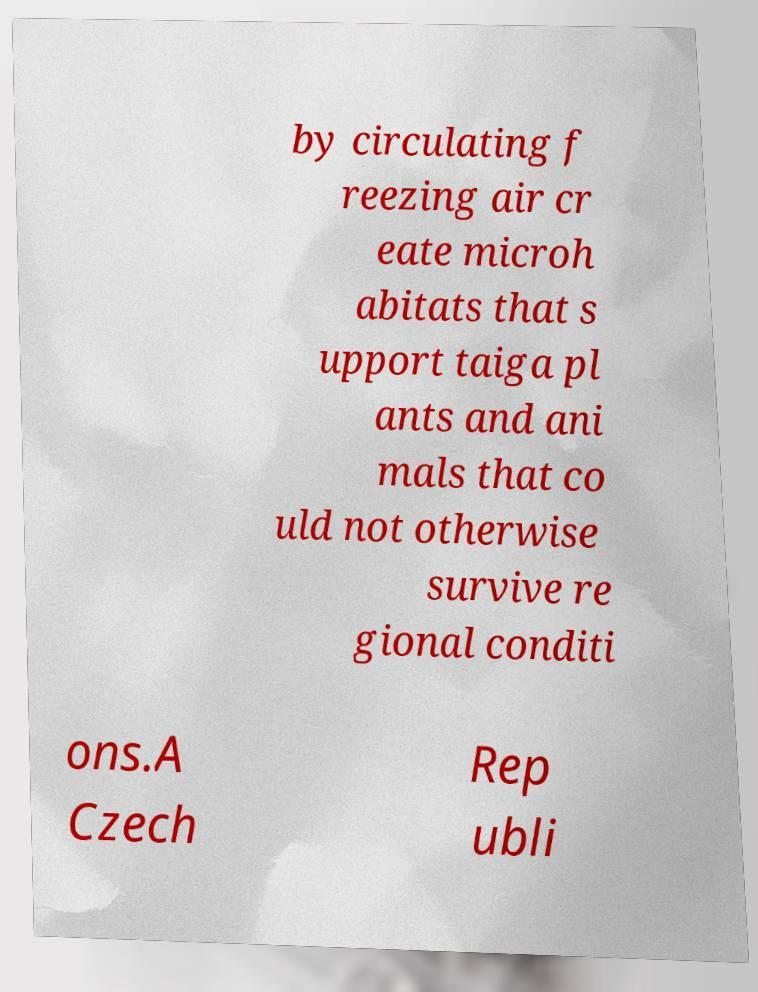Could you extract and type out the text from this image? by circulating f reezing air cr eate microh abitats that s upport taiga pl ants and ani mals that co uld not otherwise survive re gional conditi ons.A Czech Rep ubli 